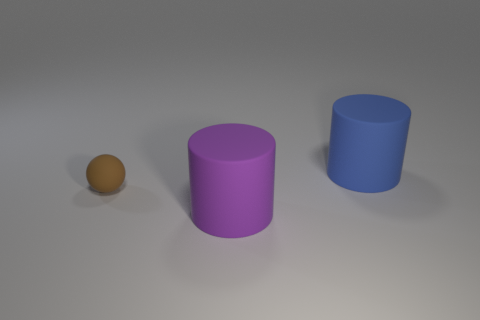There is a purple thing that is the same shape as the large blue object; what is it made of?
Your answer should be very brief. Rubber. Are there any other things that have the same size as the purple rubber thing?
Your answer should be very brief. Yes. Are any cyan metallic cylinders visible?
Keep it short and to the point. No. What is the material of the tiny ball that is behind the large matte object that is on the left side of the big cylinder behind the tiny rubber thing?
Give a very brief answer. Rubber. There is a big blue matte thing; is its shape the same as the rubber object that is in front of the tiny rubber ball?
Give a very brief answer. Yes. What number of other large objects are the same shape as the blue matte object?
Make the answer very short. 1. The purple thing has what shape?
Keep it short and to the point. Cylinder. There is a matte cylinder on the left side of the large rubber cylinder behind the small matte ball; what size is it?
Ensure brevity in your answer.  Large. How many objects are large purple rubber cylinders or big blue rubber cylinders?
Your answer should be compact. 2. Do the big purple matte thing and the blue thing have the same shape?
Provide a short and direct response. Yes. 